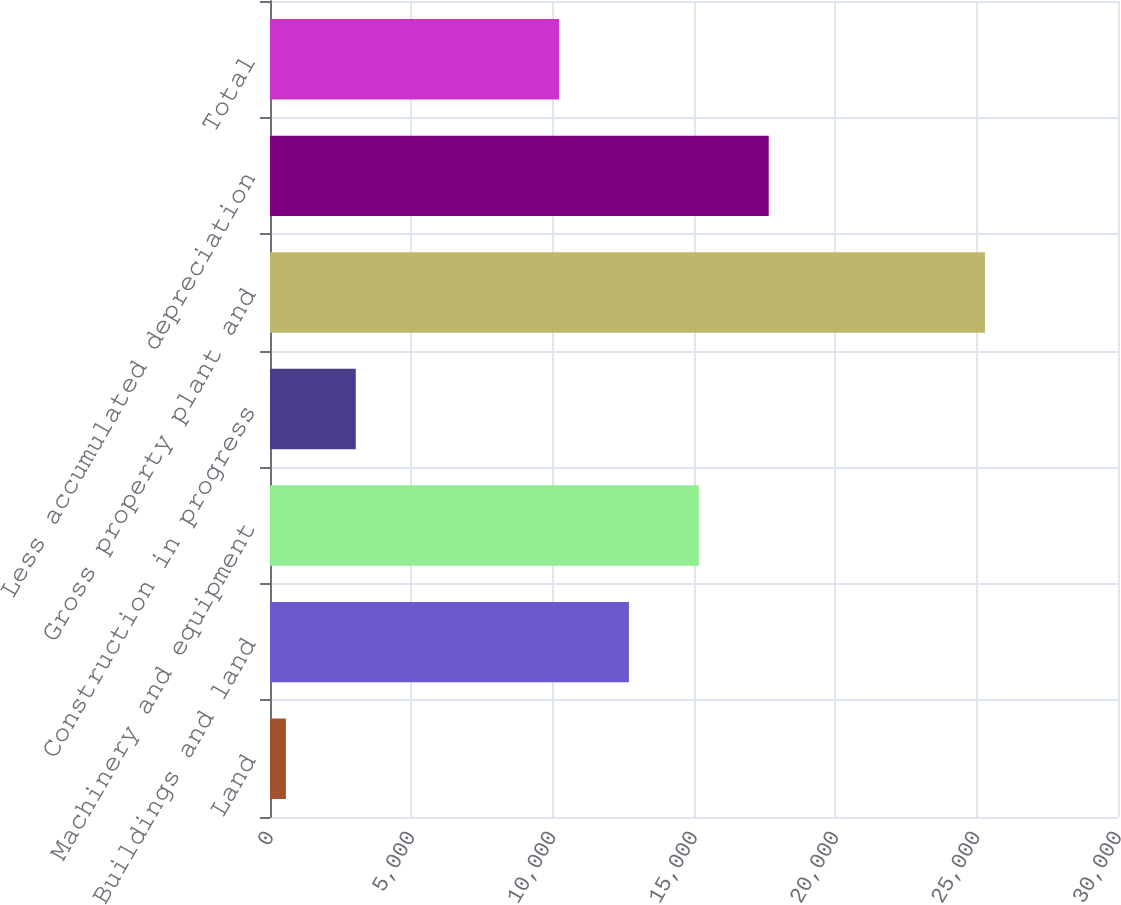Convert chart. <chart><loc_0><loc_0><loc_500><loc_500><bar_chart><fcel>Land<fcel>Buildings and land<fcel>Machinery and equipment<fcel>Construction in progress<fcel>Gross property plant and<fcel>Less accumulated depreciation<fcel>Total<nl><fcel>562<fcel>12697.2<fcel>15170.4<fcel>3035.2<fcel>25294<fcel>17643.6<fcel>10224<nl></chart> 